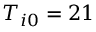<formula> <loc_0><loc_0><loc_500><loc_500>T _ { i 0 } = 2 1</formula> 